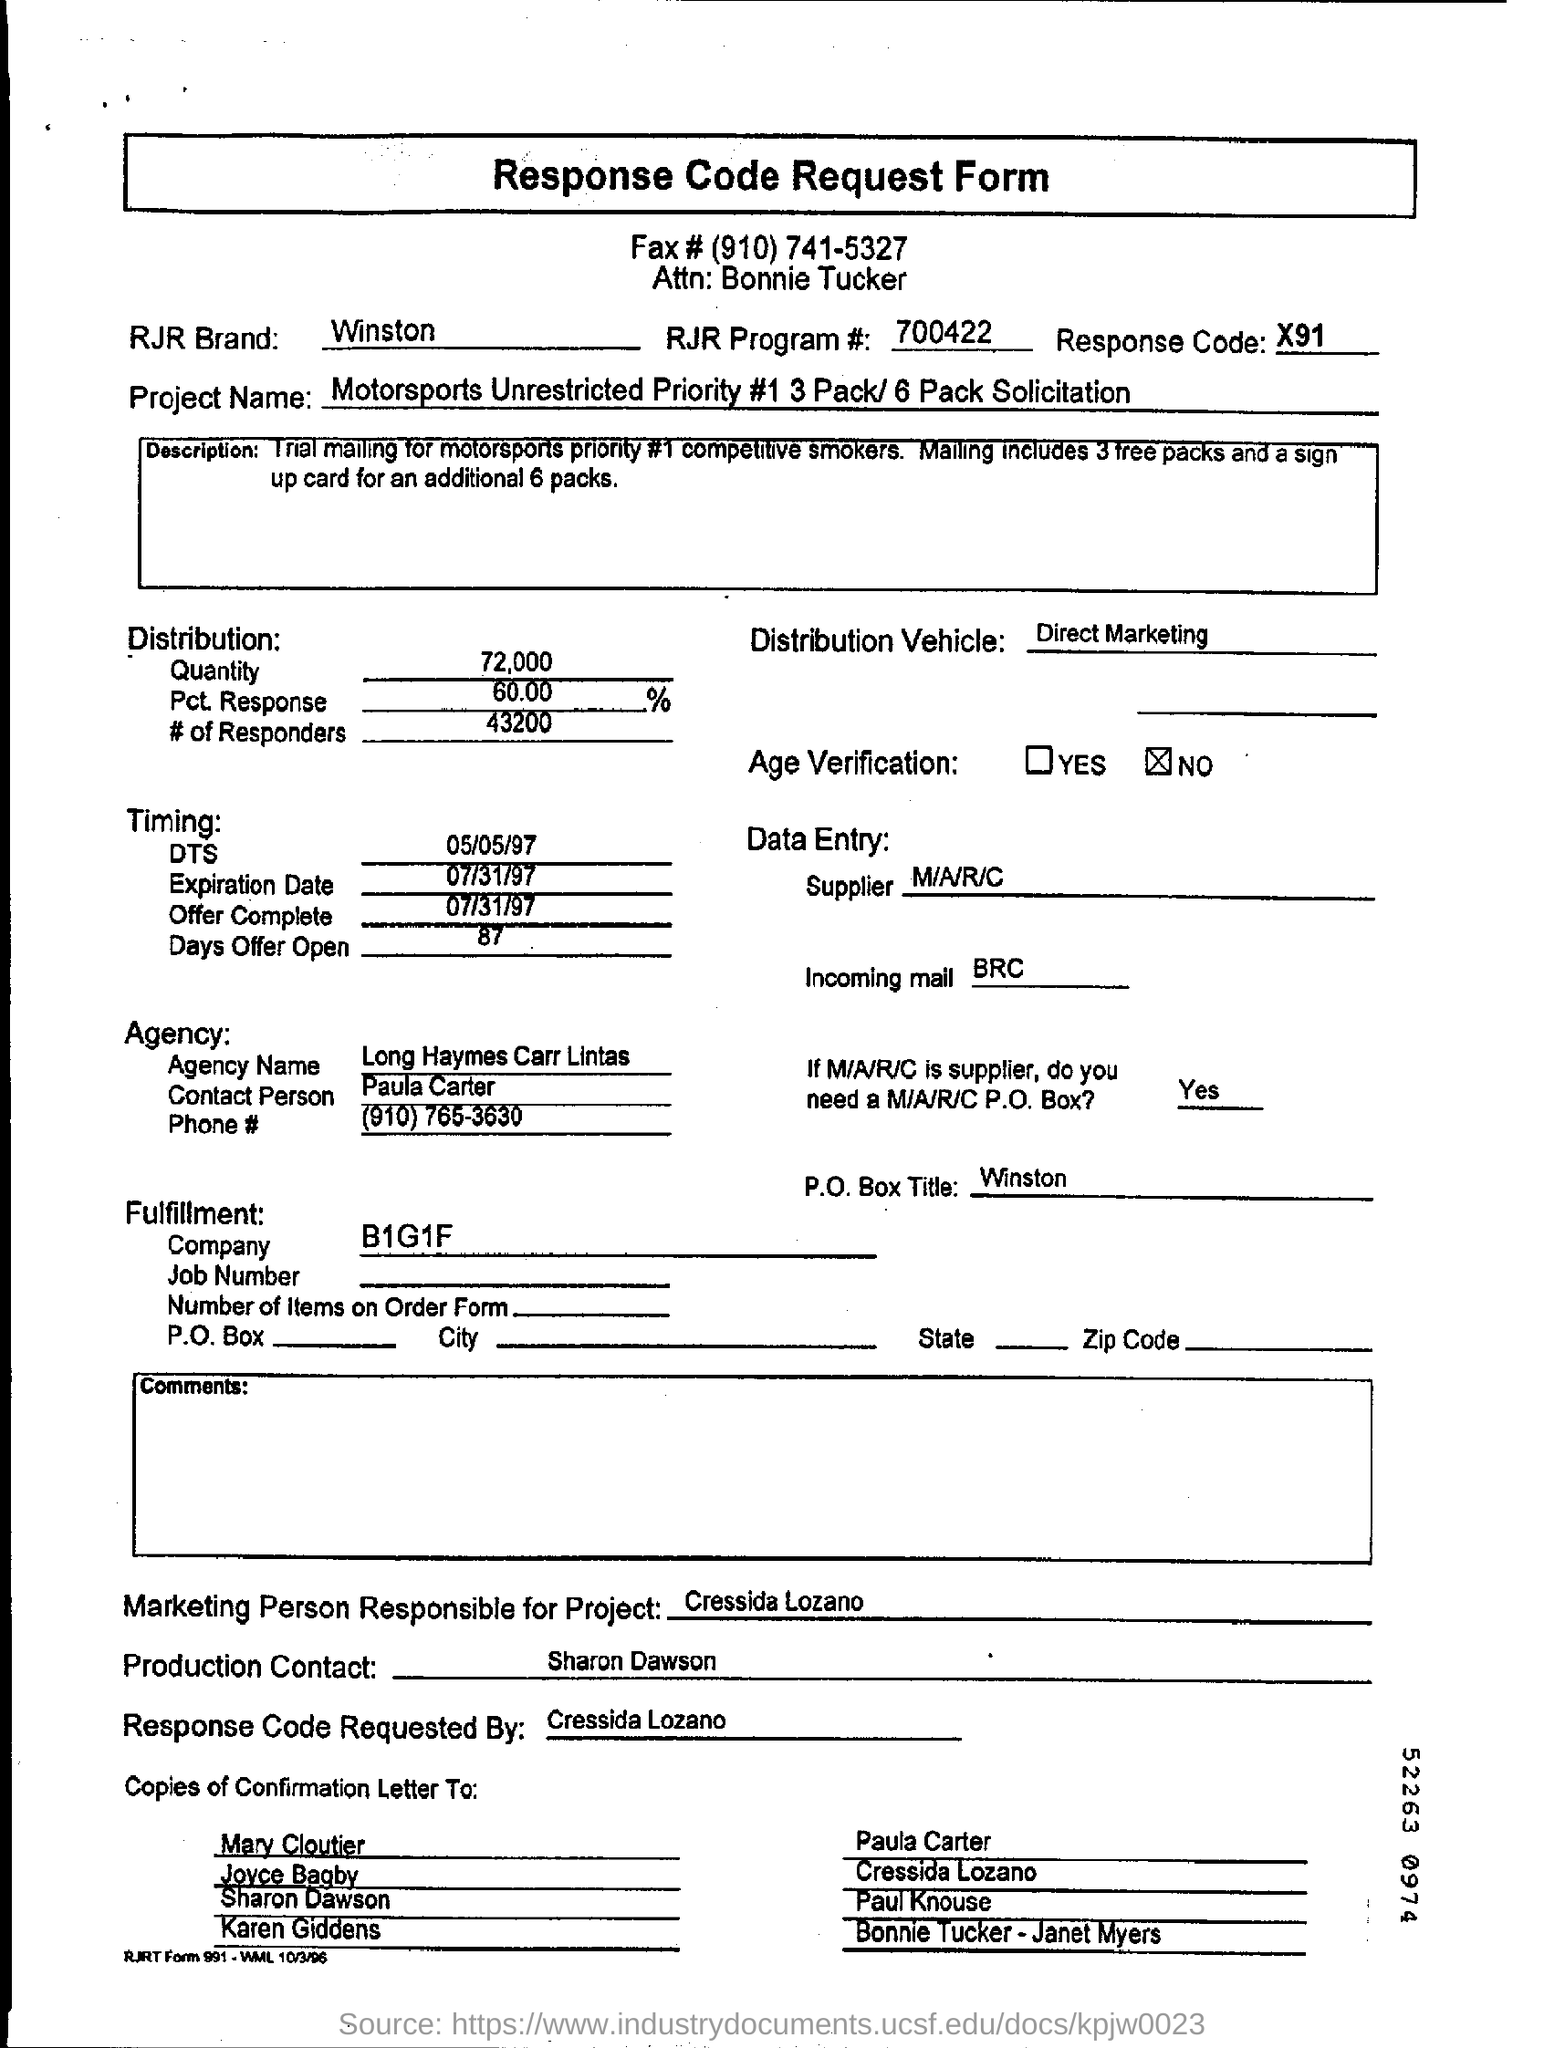what is the expiration date mentioned ? The expiration date mentioned on the document is 07/31/97. It signifies the final date on which the offer described in the form was considered valid. 